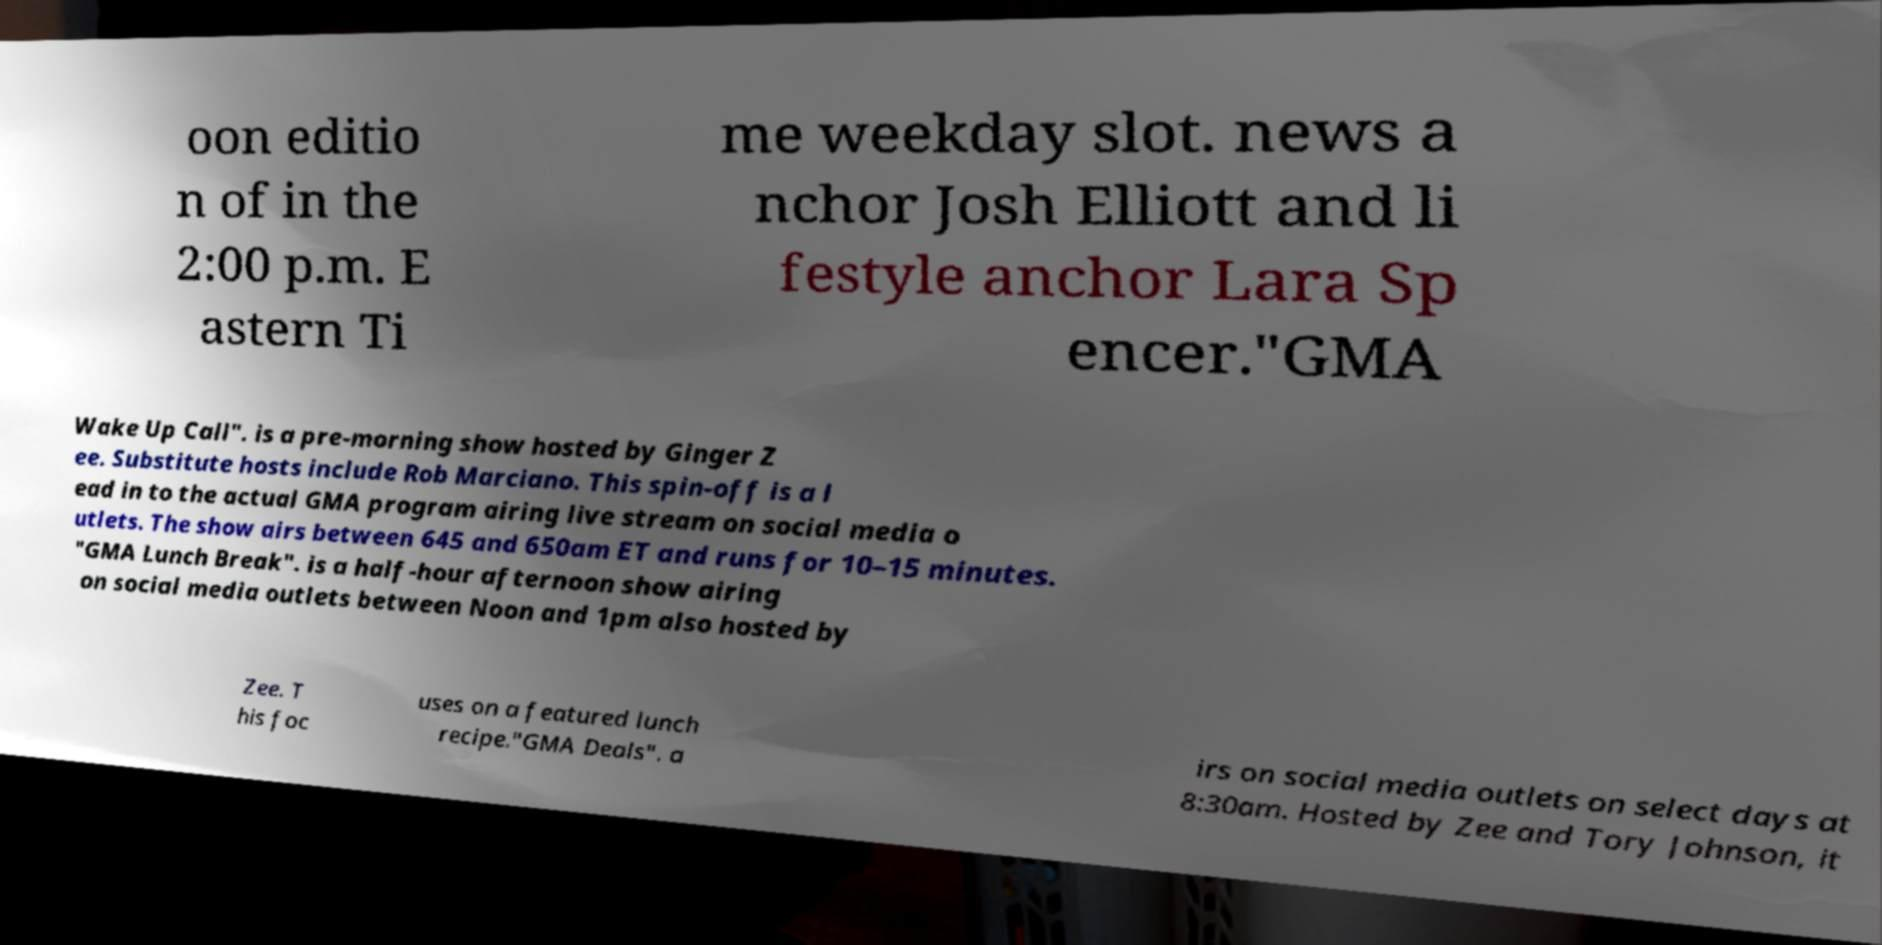Can you accurately transcribe the text from the provided image for me? oon editio n of in the 2:00 p.m. E astern Ti me weekday slot. news a nchor Josh Elliott and li festyle anchor Lara Sp encer."GMA Wake Up Call". is a pre-morning show hosted by Ginger Z ee. Substitute hosts include Rob Marciano. This spin-off is a l ead in to the actual GMA program airing live stream on social media o utlets. The show airs between 645 and 650am ET and runs for 10–15 minutes. "GMA Lunch Break". is a half-hour afternoon show airing on social media outlets between Noon and 1pm also hosted by Zee. T his foc uses on a featured lunch recipe."GMA Deals". a irs on social media outlets on select days at 8:30am. Hosted by Zee and Tory Johnson, it 